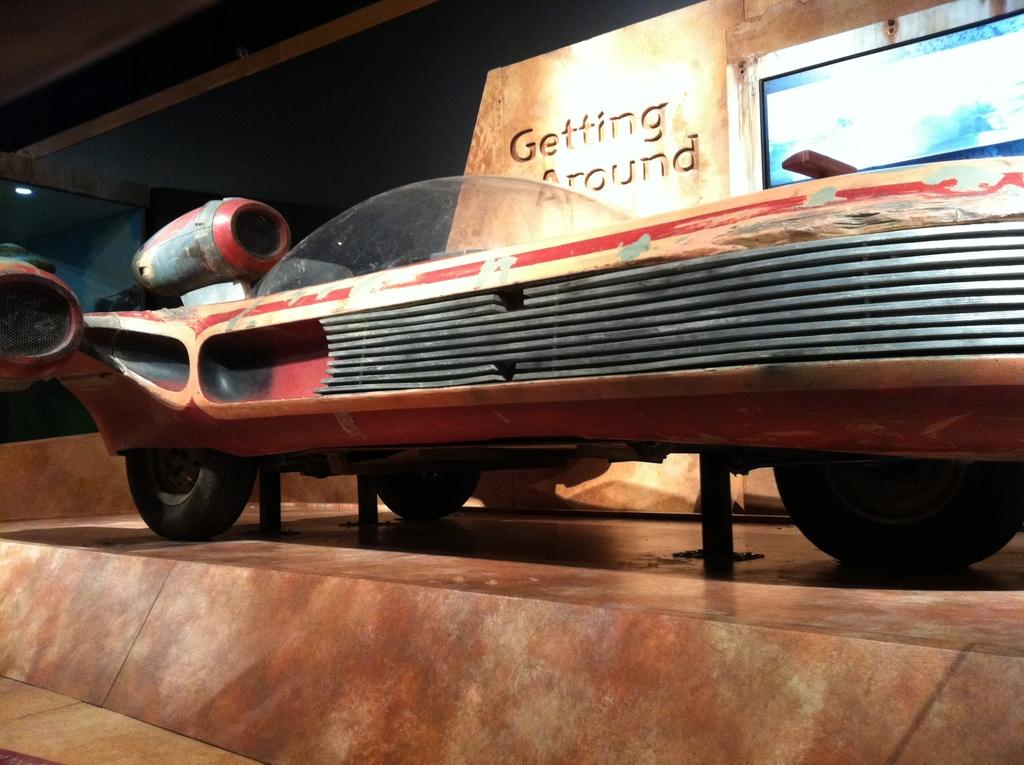What is the main subject in the image? There is a vehicle in the image. What can be seen in the background of the image? There is a building in the background of the image. Can you describe any text or writing in the image? There is text on a wall in the image. What type of device or object is present with the text? There is a screen in the image. How many times do the characters in the image share a kiss? There are no characters or kisses present in the image; it features a vehicle, a building, text on a wall, and a screen. 